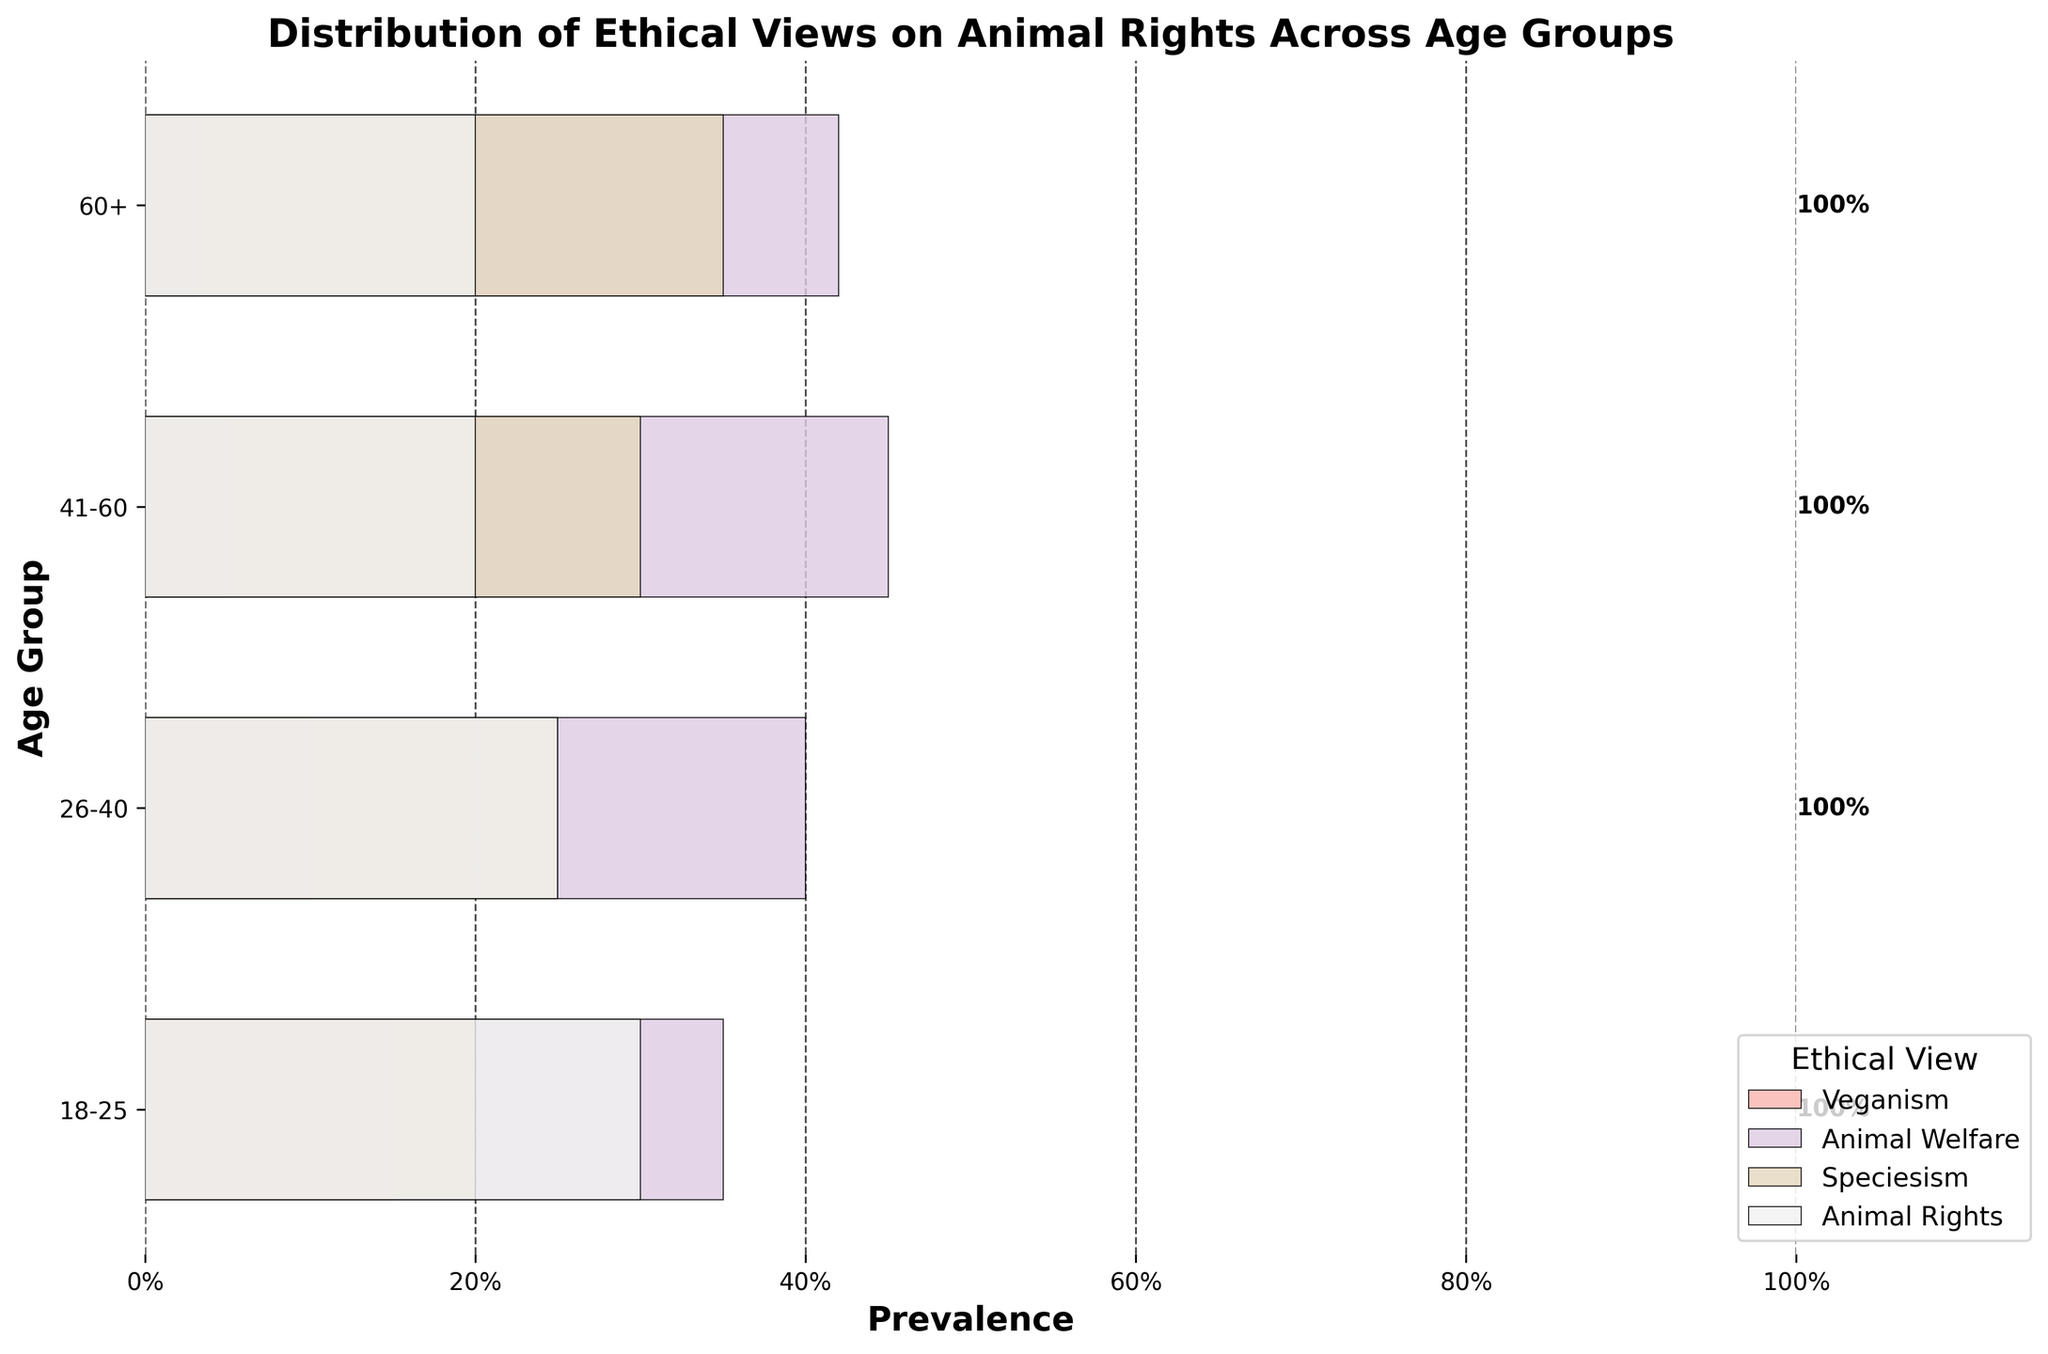What is the title of the figure? The title of the figure is found at the top of the plot and summarizes the information presented.
Answer: Distribution of Ethical Views on Animal Rights Across Age Groups Which age group has the highest prevalence of 'Animal Welfare' views? Look at the bar corresponding to 'Animal Welfare' within each age group and determine which one is the longest.
Answer: 41-60 Which ethical view is least prevalent in the 60+ age group? Compare the lengths of the bars representing each ethical view for the 60+ age group and find the shortest one.
Answer: Veganism What is the total prevalence of 'Animal Rights' views across all age groups? Sum the prevalence values for 'Animal Rights' across all age groups. 0.30 (18-25) + 0.25 (26-40) + 0.20 (41-60) + 0.20 (60+).
Answer: 0.95 How does the prevalence of 'Veganism' compare between the youngest (18-25) and oldest (60+) age groups? Subtract the prevalence of 'Veganism' in the 60+ age group from that in the 18-25 age group. 0.15 (18-25) - 0.03 (60+).
Answer: 0.12 Which ethical view shows the most consistent prevalence across all age groups? Calculate the difference in prevalence for each ethical view between the different age groups and identify the view with the smallest differences.
Answer: Animal Welfare What is the combined prevalence of 'Speciesism' and 'Veganism' in the 26-40 age group? Add the prevalence values for 'Speciesism' and 'Veganism' in the 26-40 age group. 0.25 (Speciesism) + 0.10 (Veganism).
Answer: 0.35 In which age group is the combined prevalence of 'Animal Welfare' and 'Animal Rights' highest? Sum the prevalence values of 'Animal Welfare' and 'Animal Rights' for each age group and find the maximum. 
18-25: 0.35 + 0.30 = 0.65, 26-40: 0.40 + 0.25 = 0.65, 41-60: 0.45 + 0.20 = 0.65, 60+: 0.42 + 0.20 = 0.62.
Answer: 18-25, 26-40, and 41-60 (tie) What is the overall trend in the prevalence of 'Veganism' as age increases? Observe the 'Veganism' bars across the age groups and note any changes in length. The trend shows a consistent decrease.
Answer: Decreasing How does the prevalence of 'Animal Rights' in the 26-40 age group compare to 'Speciesism' in the same group? Compare the length of the 'Animal Rights' bar to the 'Speciesism' bar within the 26-40 age group. 'Animal Rights' (0.25) and 'Speciesism' (0.25).
Answer: Equal 